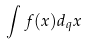<formula> <loc_0><loc_0><loc_500><loc_500>\int f ( x ) d _ { q } x</formula> 